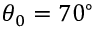<formula> <loc_0><loc_0><loc_500><loc_500>\theta _ { 0 } = 7 0 ^ { \circ }</formula> 